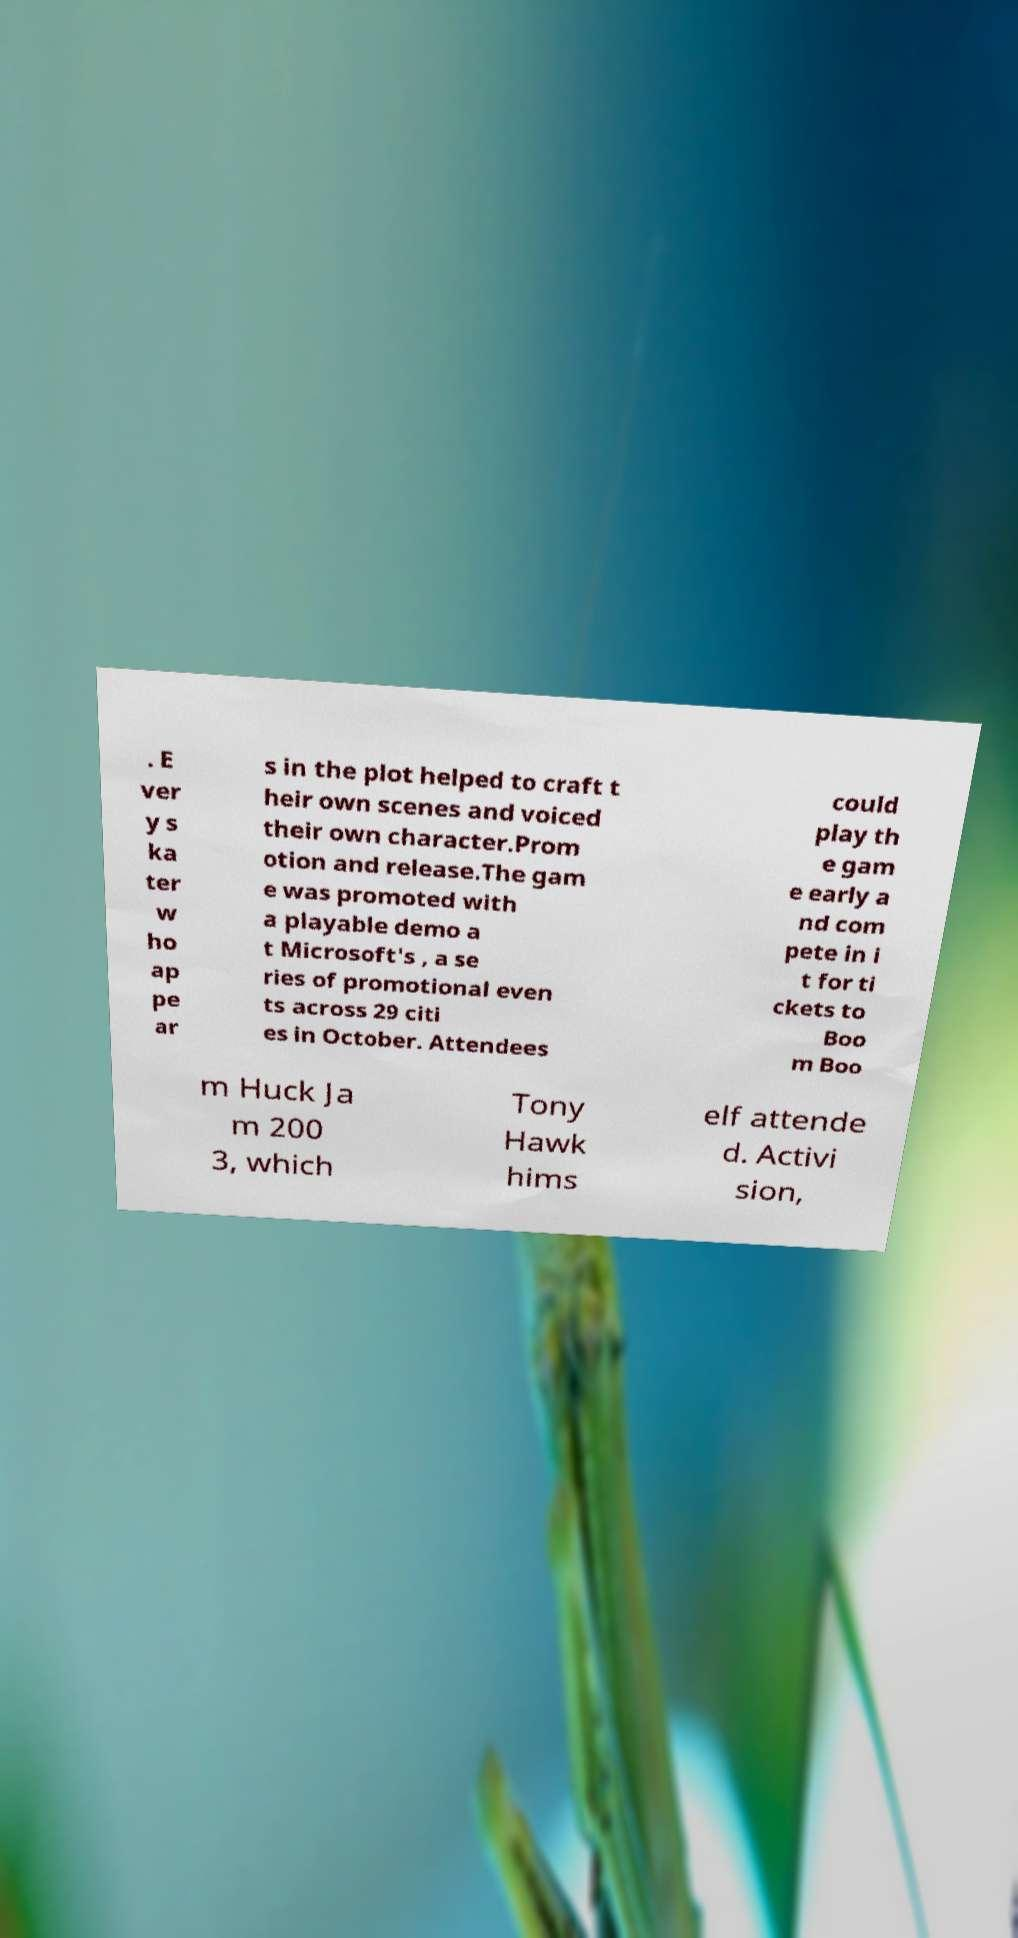I need the written content from this picture converted into text. Can you do that? . E ver y s ka ter w ho ap pe ar s in the plot helped to craft t heir own scenes and voiced their own character.Prom otion and release.The gam e was promoted with a playable demo a t Microsoft's , a se ries of promotional even ts across 29 citi es in October. Attendees could play th e gam e early a nd com pete in i t for ti ckets to Boo m Boo m Huck Ja m 200 3, which Tony Hawk hims elf attende d. Activi sion, 